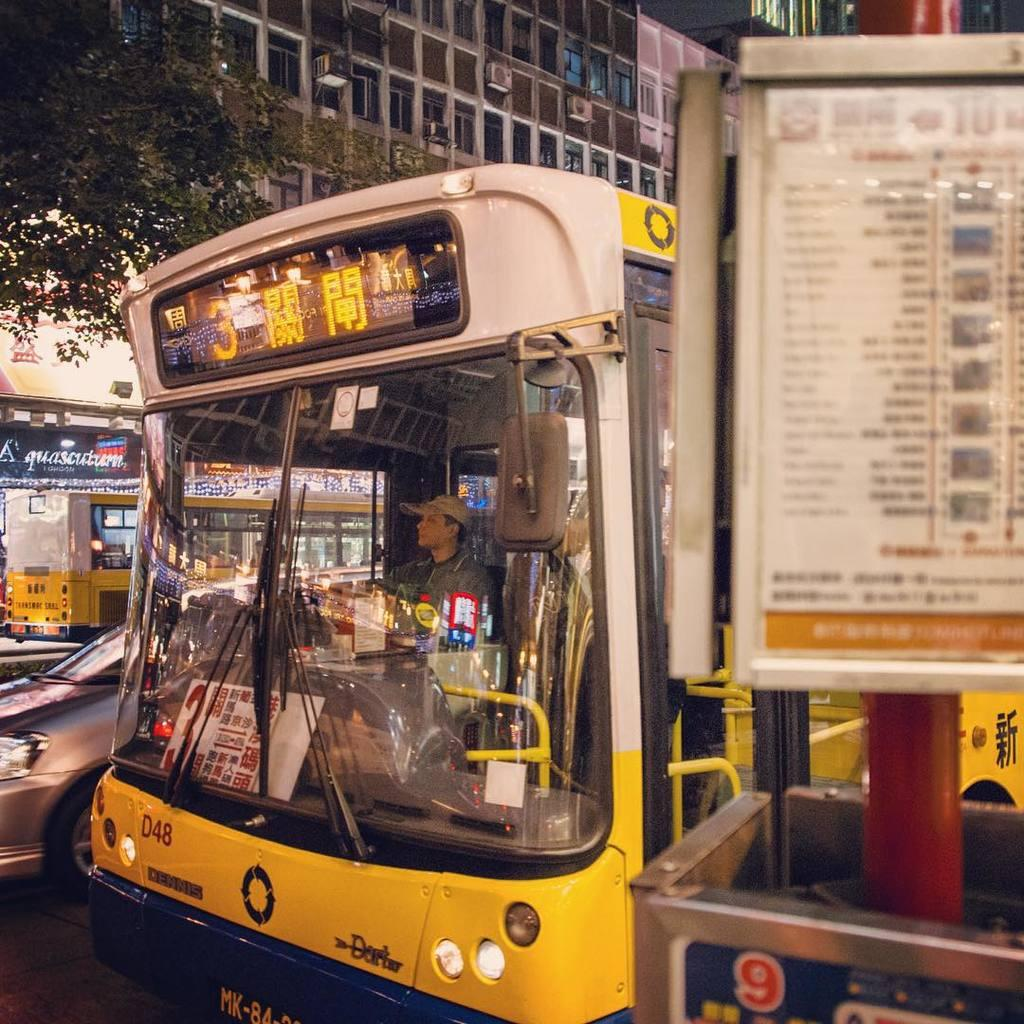<image>
Render a clear and concise summary of the photo. The number 3 bus is yellow and stopped at the bus stop. 